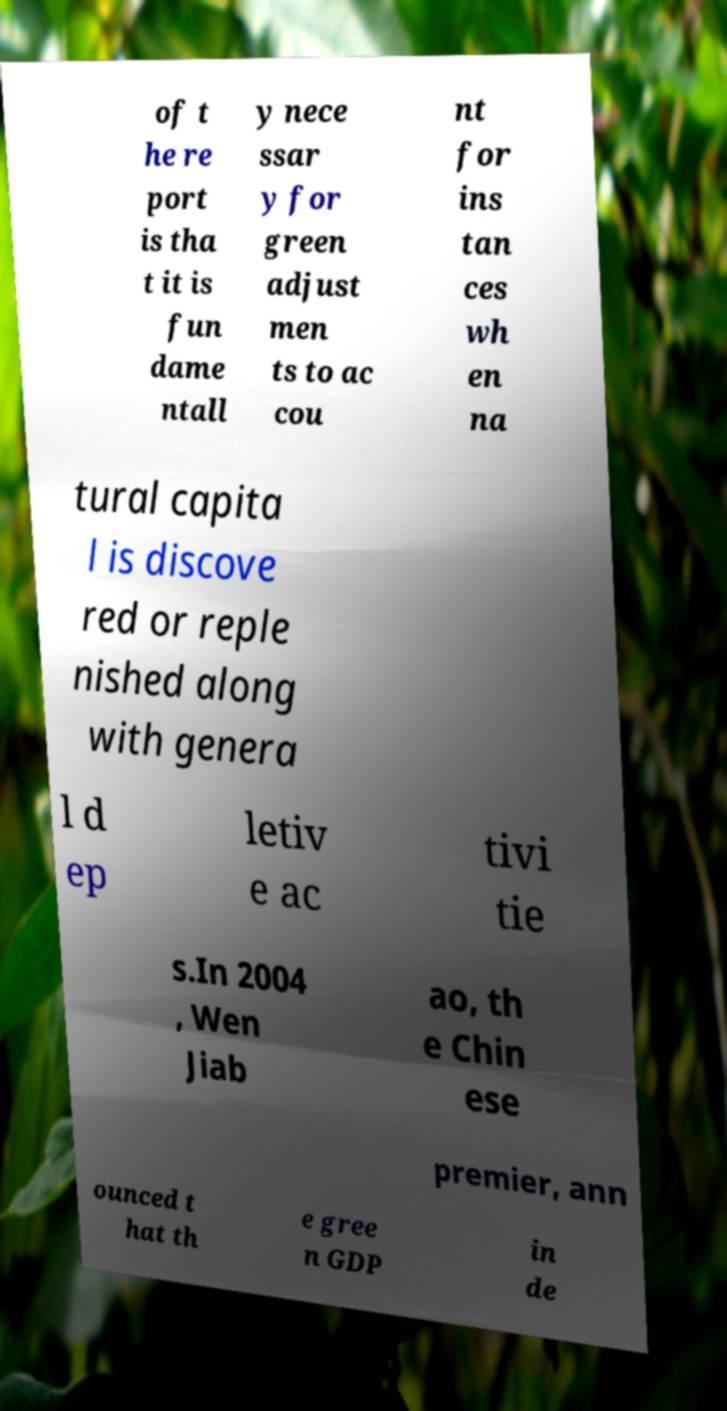Can you accurately transcribe the text from the provided image for me? of t he re port is tha t it is fun dame ntall y nece ssar y for green adjust men ts to ac cou nt for ins tan ces wh en na tural capita l is discove red or reple nished along with genera l d ep letiv e ac tivi tie s.In 2004 , Wen Jiab ao, th e Chin ese premier, ann ounced t hat th e gree n GDP in de 